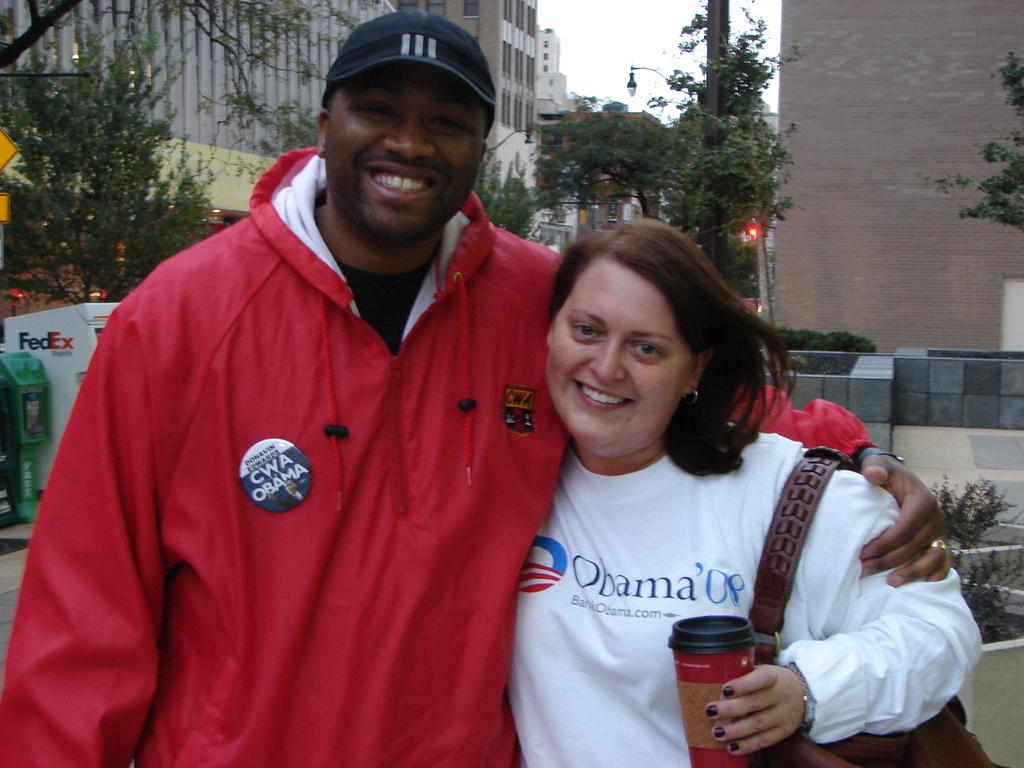<image>
Share a concise interpretation of the image provided. A woman wearing an Obama 08 shirt is posing with a man in a red jacket. 